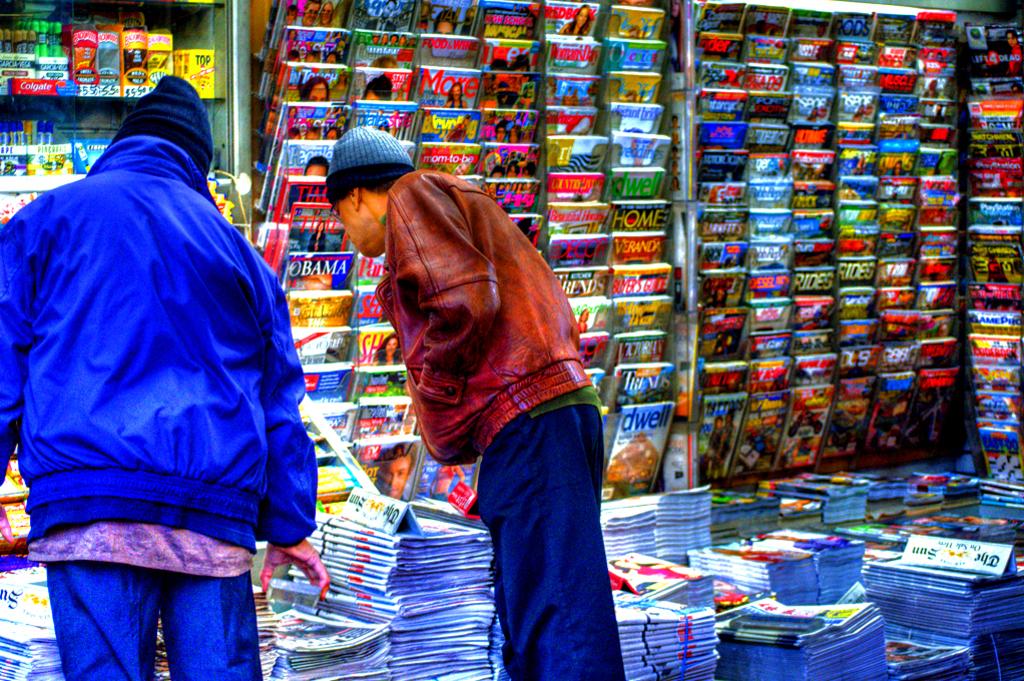What is the magazine above dwell?
Provide a short and direct response. Trends. 